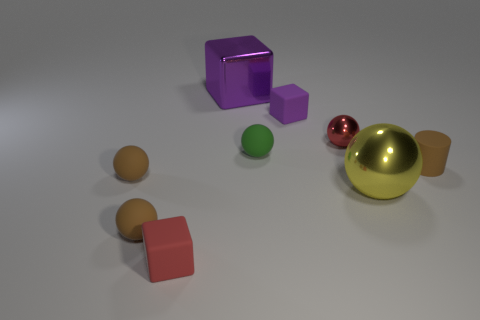Do the tiny shiny ball and the small rubber block that is left of the green rubber sphere have the same color?
Offer a very short reply. Yes. What number of yellow objects are large shiny blocks or large metallic objects?
Offer a terse response. 1. What number of green metal objects are the same size as the red matte thing?
Make the answer very short. 0. What is the shape of the rubber object that is the same color as the large block?
Your answer should be very brief. Cube. What number of things are large red rubber objects or brown objects behind the yellow metal sphere?
Your answer should be compact. 2. There is a green matte sphere right of the large purple thing; is it the same size as the matte block that is in front of the small brown rubber cylinder?
Your response must be concise. Yes. How many tiny red rubber things are the same shape as the purple metallic object?
Offer a terse response. 1. What is the shape of the small red thing that is made of the same material as the green sphere?
Offer a very short reply. Cube. What is the material of the large purple thing left of the large metallic object that is right of the red metal sphere on the left side of the tiny rubber cylinder?
Your response must be concise. Metal. There is a purple metallic block; is its size the same as the shiny thing to the right of the tiny red metallic sphere?
Give a very brief answer. Yes. 